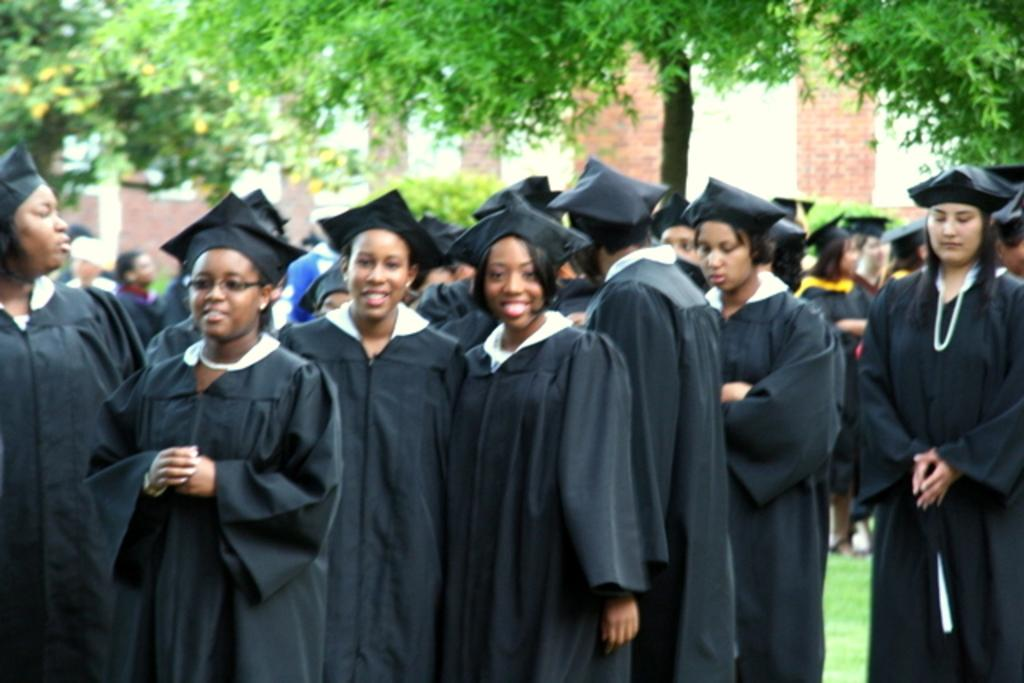Who can be seen in the foreground of the image? There are women in the foreground of the image. What are the women wearing in the image? The women are wearing convocation dresses and convocation hats on their heads. What can be seen in the background of the image? There are trees and a wall in the background of the image. What book is the donkey reading in the image? There is no donkey or book present in the image. 